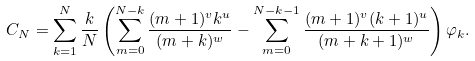<formula> <loc_0><loc_0><loc_500><loc_500>C _ { N } = \sum _ { k = 1 } ^ { N } \frac { k } { N } \left ( \sum _ { m = 0 } ^ { N - k } \frac { ( m + 1 ) ^ { v } k ^ { u } } { ( m + k ) ^ { w } } - \sum _ { m = 0 } ^ { N - k - 1 } \frac { ( m + 1 ) ^ { v } ( k + 1 ) ^ { u } } { ( m + k + 1 ) ^ { w } } \right ) \varphi _ { k } .</formula> 